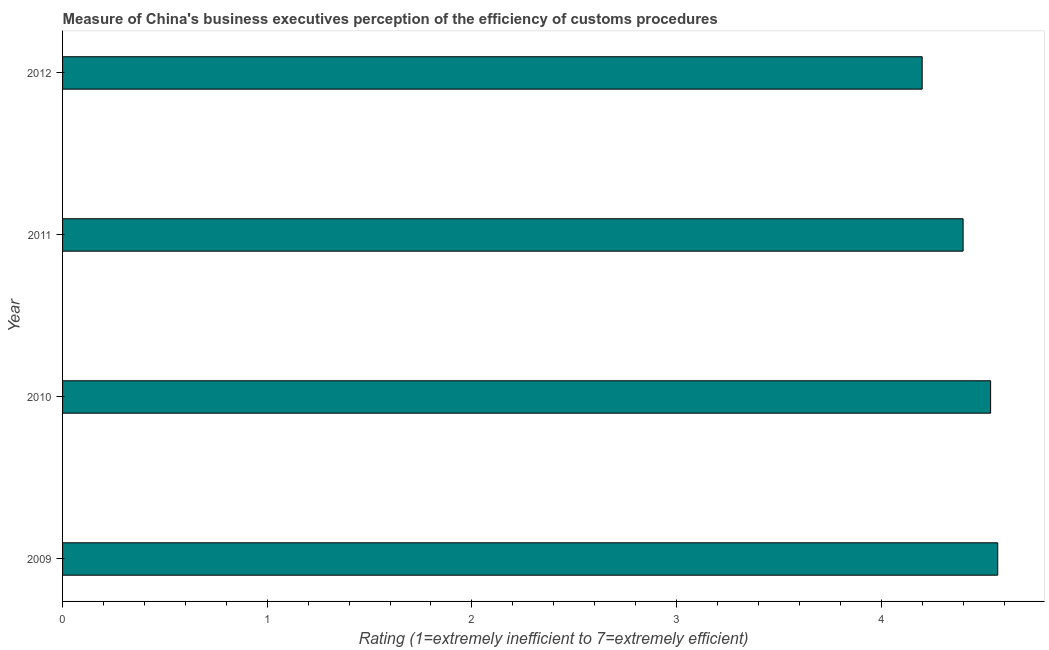Does the graph contain grids?
Keep it short and to the point. No. What is the title of the graph?
Make the answer very short. Measure of China's business executives perception of the efficiency of customs procedures. What is the label or title of the X-axis?
Keep it short and to the point. Rating (1=extremely inefficient to 7=extremely efficient). What is the label or title of the Y-axis?
Keep it short and to the point. Year. What is the rating measuring burden of customs procedure in 2011?
Your answer should be very brief. 4.4. Across all years, what is the maximum rating measuring burden of customs procedure?
Your response must be concise. 4.57. What is the sum of the rating measuring burden of customs procedure?
Keep it short and to the point. 17.7. What is the difference between the rating measuring burden of customs procedure in 2010 and 2011?
Ensure brevity in your answer.  0.13. What is the average rating measuring burden of customs procedure per year?
Offer a terse response. 4.43. What is the median rating measuring burden of customs procedure?
Ensure brevity in your answer.  4.47. In how many years, is the rating measuring burden of customs procedure greater than 3.4 ?
Provide a short and direct response. 4. What is the ratio of the rating measuring burden of customs procedure in 2009 to that in 2011?
Your answer should be compact. 1.04. Is the difference between the rating measuring burden of customs procedure in 2010 and 2012 greater than the difference between any two years?
Ensure brevity in your answer.  No. What is the difference between the highest and the second highest rating measuring burden of customs procedure?
Your response must be concise. 0.04. What is the difference between the highest and the lowest rating measuring burden of customs procedure?
Provide a short and direct response. 0.37. In how many years, is the rating measuring burden of customs procedure greater than the average rating measuring burden of customs procedure taken over all years?
Ensure brevity in your answer.  2. Are all the bars in the graph horizontal?
Give a very brief answer. Yes. What is the Rating (1=extremely inefficient to 7=extremely efficient) of 2009?
Your response must be concise. 4.57. What is the Rating (1=extremely inefficient to 7=extremely efficient) of 2010?
Provide a short and direct response. 4.53. What is the Rating (1=extremely inefficient to 7=extremely efficient) in 2011?
Your answer should be very brief. 4.4. What is the Rating (1=extremely inefficient to 7=extremely efficient) of 2012?
Provide a short and direct response. 4.2. What is the difference between the Rating (1=extremely inefficient to 7=extremely efficient) in 2009 and 2010?
Give a very brief answer. 0.03. What is the difference between the Rating (1=extremely inefficient to 7=extremely efficient) in 2009 and 2011?
Keep it short and to the point. 0.17. What is the difference between the Rating (1=extremely inefficient to 7=extremely efficient) in 2009 and 2012?
Make the answer very short. 0.37. What is the difference between the Rating (1=extremely inefficient to 7=extremely efficient) in 2010 and 2011?
Offer a terse response. 0.13. What is the difference between the Rating (1=extremely inefficient to 7=extremely efficient) in 2010 and 2012?
Give a very brief answer. 0.33. What is the difference between the Rating (1=extremely inefficient to 7=extremely efficient) in 2011 and 2012?
Offer a terse response. 0.2. What is the ratio of the Rating (1=extremely inefficient to 7=extremely efficient) in 2009 to that in 2011?
Offer a very short reply. 1.04. What is the ratio of the Rating (1=extremely inefficient to 7=extremely efficient) in 2009 to that in 2012?
Ensure brevity in your answer.  1.09. What is the ratio of the Rating (1=extremely inefficient to 7=extremely efficient) in 2010 to that in 2011?
Keep it short and to the point. 1.03. What is the ratio of the Rating (1=extremely inefficient to 7=extremely efficient) in 2010 to that in 2012?
Offer a terse response. 1.08. What is the ratio of the Rating (1=extremely inefficient to 7=extremely efficient) in 2011 to that in 2012?
Make the answer very short. 1.05. 